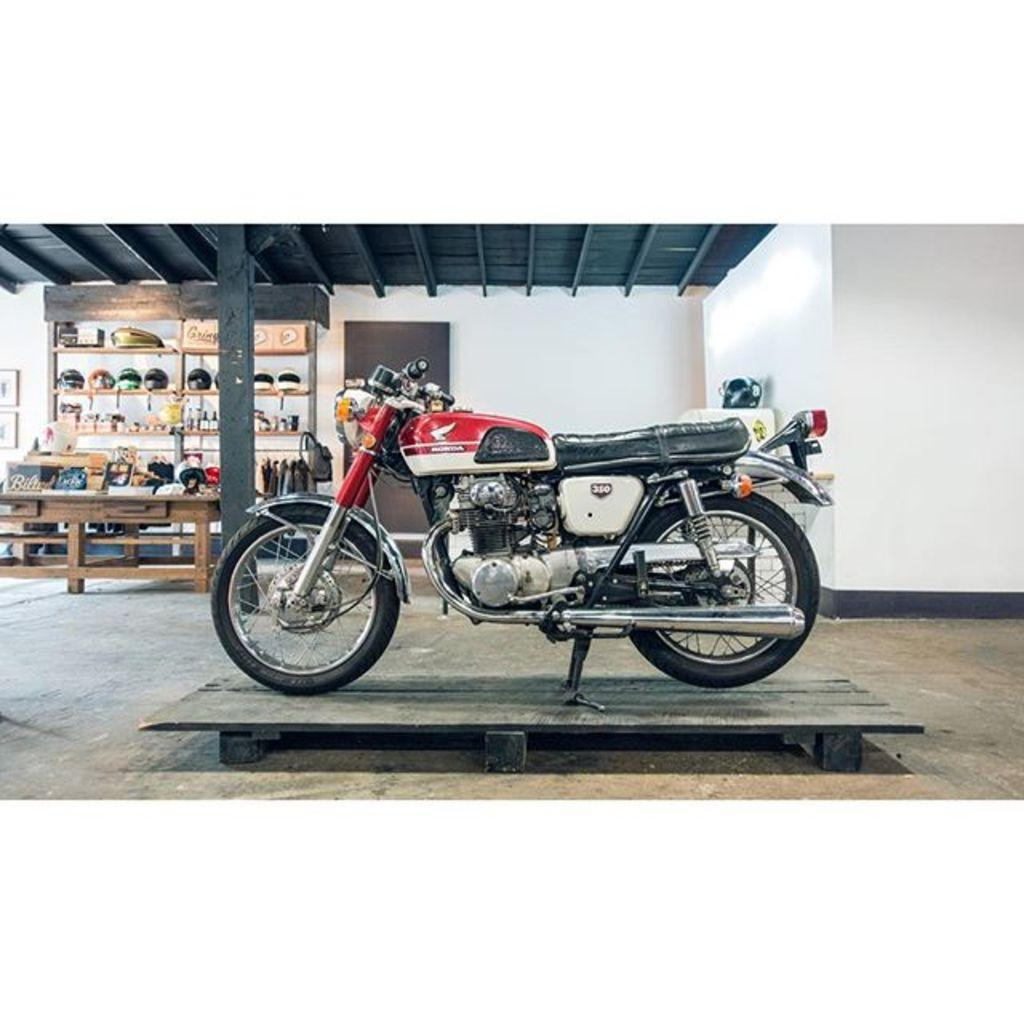What is the main subject in the center of the image? There is a bike in the center of the image. Where is the bike located? The bike is on the floor. What can be seen in the background of the image? There are helmets, objects arranged in shelves, a door, and a wall in the background. What type of grape is growing on the wall in the image? There are no grapes present in the image; the wall in the background is empty. 